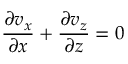<formula> <loc_0><loc_0><loc_500><loc_500>\frac { \partial v _ { x } } { \partial x } + \frac { \partial v _ { z } } { \partial z } = 0</formula> 